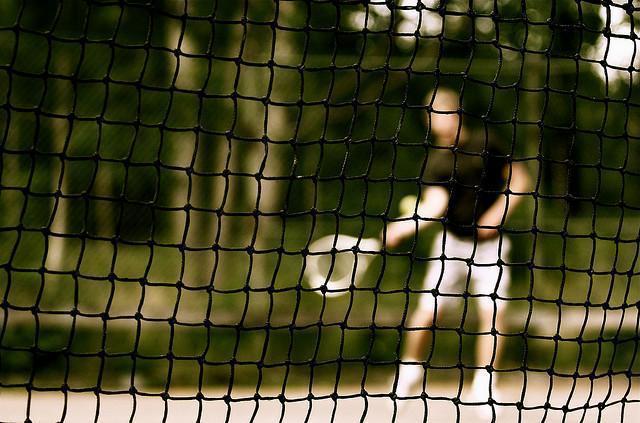This person is playing a similar sport to whom?
Make your selection and explain in format: 'Answer: answer
Rationale: rationale.'
Options: Lennox lewis, serena williams, jordan spieth, bucky dent. Answer: serena williams.
Rationale: The person is williams. 